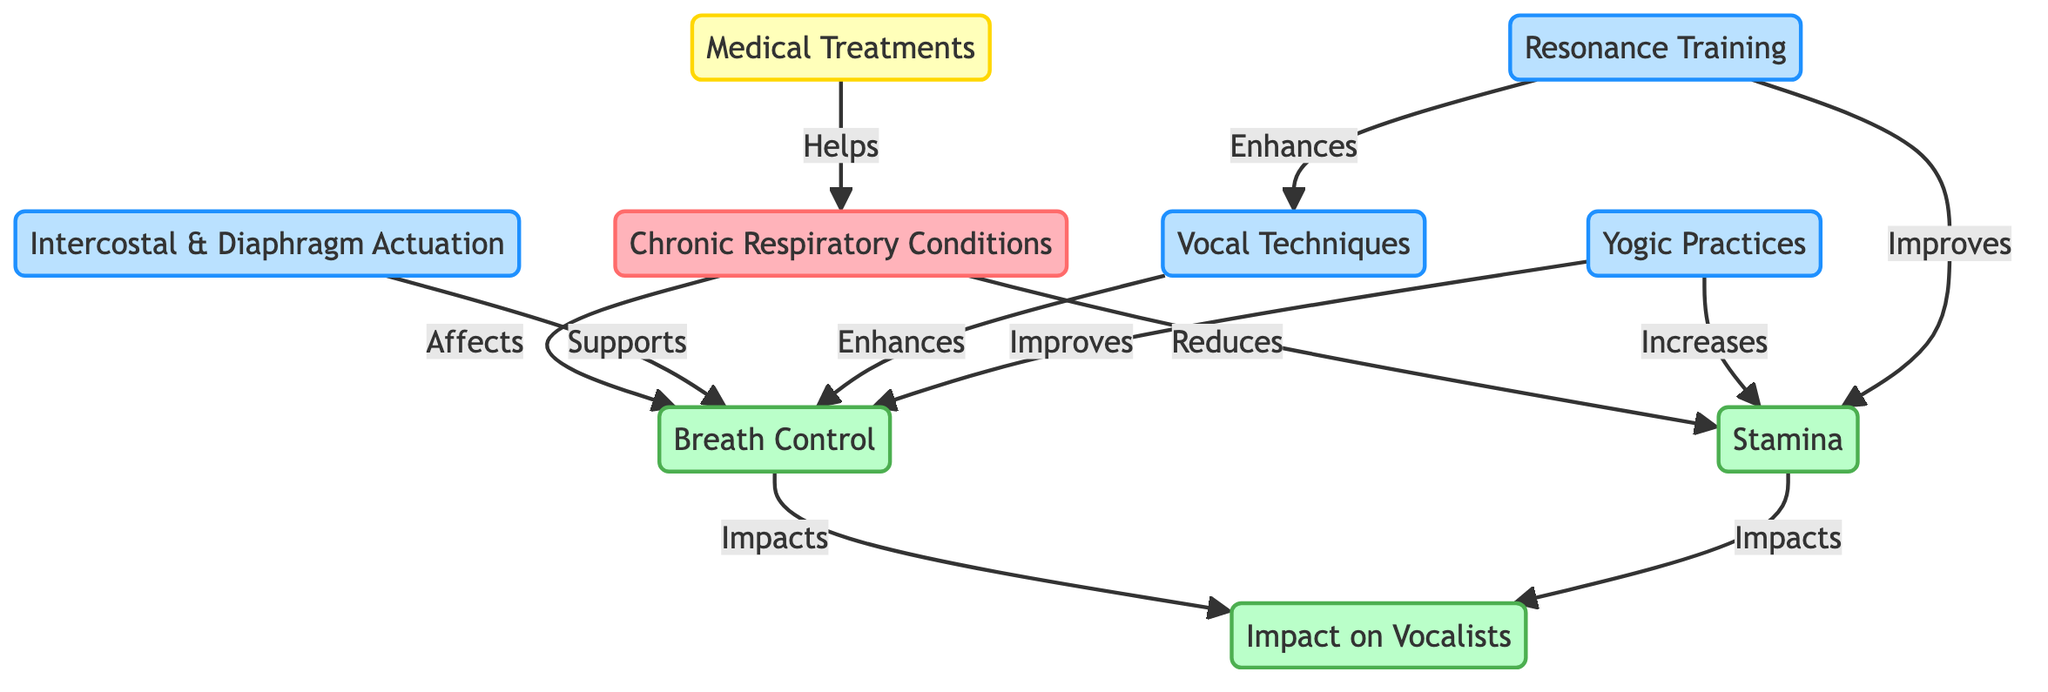What conditions are represented in the diagram? The diagram features "Chronic Respiratory Conditions" as the primary condition affecting vocalists. It is explicitly stated at the starting point of the flowchart.
Answer: Chronic Respiratory Conditions What techniques are used to support breath control? Three techniques listed in the diagram that support breath control are "Intercostal & Diaphragm Actuation," "Vocal Techniques," and "Yogic Practices."
Answer: Intercostal & Diaphragm Actuation, Vocal Techniques, Yogic Practices How do chronic respiratory conditions impact stamina? The diagram indicates that chronic respiratory conditions specifically lead to a reduction in stamina, as denoted by the arrow pointing from CRC to ST.
Answer: Reduces Which technique improves stamina? The diagram shows that "Yogic Practices" significantly increases stamina, indicated by the direct effect of YP on ST.
Answer: Yogic Practices How many impacts are there on vocalists? The diagram lists two primary impacts on vocalists from breath control and stamina, both of which connect to the "Impact on Vocalists" node.
Answer: 2 What is the relationship between vocal techniques and breath control? The diagram illustrates that "Vocal Techniques," as a technique, enhances breath control by directing an arrow from VT to BC, therefore indicating a supportive relationship.
Answer: Enhances What treatments help chronic respiratory conditions? The diagram lists "Medical Treatments" as the treatment that helps manage chronic respiratory conditions, showing a connection from MT to CRC.
Answer: Medical Treatments What enhances vocal techniques? The diagram shows that "Resonance Training" enhances vocal techniques by drawing a direct arrow from RT to VT, indicating a supportive relationship.
Answer: Resonance Training Which component increases both breath control and stamina? "Yogic Practices" is indicated in the diagram as a component that improves breath control and increases stamina, as it connects to both BC and ST with directed effects.
Answer: Yogic Practices 